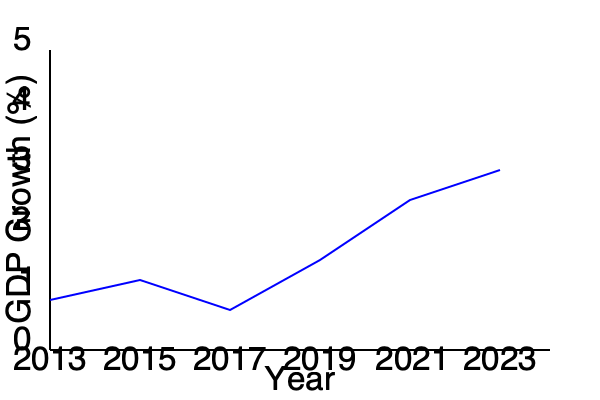Based on the line graph showing UK GDP growth from 2013 to 2023, which year appears to have had the highest GDP growth rate, and what economic event might explain this peak? To answer this question, we need to analyze the graph step-by-step:

1. The y-axis represents GDP growth as a percentage, while the x-axis shows the years from 2013 to 2023.

2. Looking at the blue line representing GDP growth, we can see that it fluctuates over the decade.

3. The highest point on the graph appears to be in 2021, indicating the highest GDP growth rate during this period.

4. To understand why 2021 shows the highest growth rate, we need to consider recent economic events:

   a. In 2020, the COVID-19 pandemic caused significant economic disruption globally, including in the UK.
   b. Many countries, including the UK, experienced economic contractions or recessions in 2020.
   c. As restrictions eased and economic activity resumed in 2021, many countries experienced a sharp rebound in economic growth.

5. This phenomenon is often referred to as a "bounce-back" or "recovery" growth, where the economy grows rapidly as it returns to pre-crisis levels.

6. The high growth rate in 2021 likely represents this recovery phase, as the UK economy rebounded from the pandemic-induced downturn of 2020.
Answer: 2021; post-COVID economic recovery 